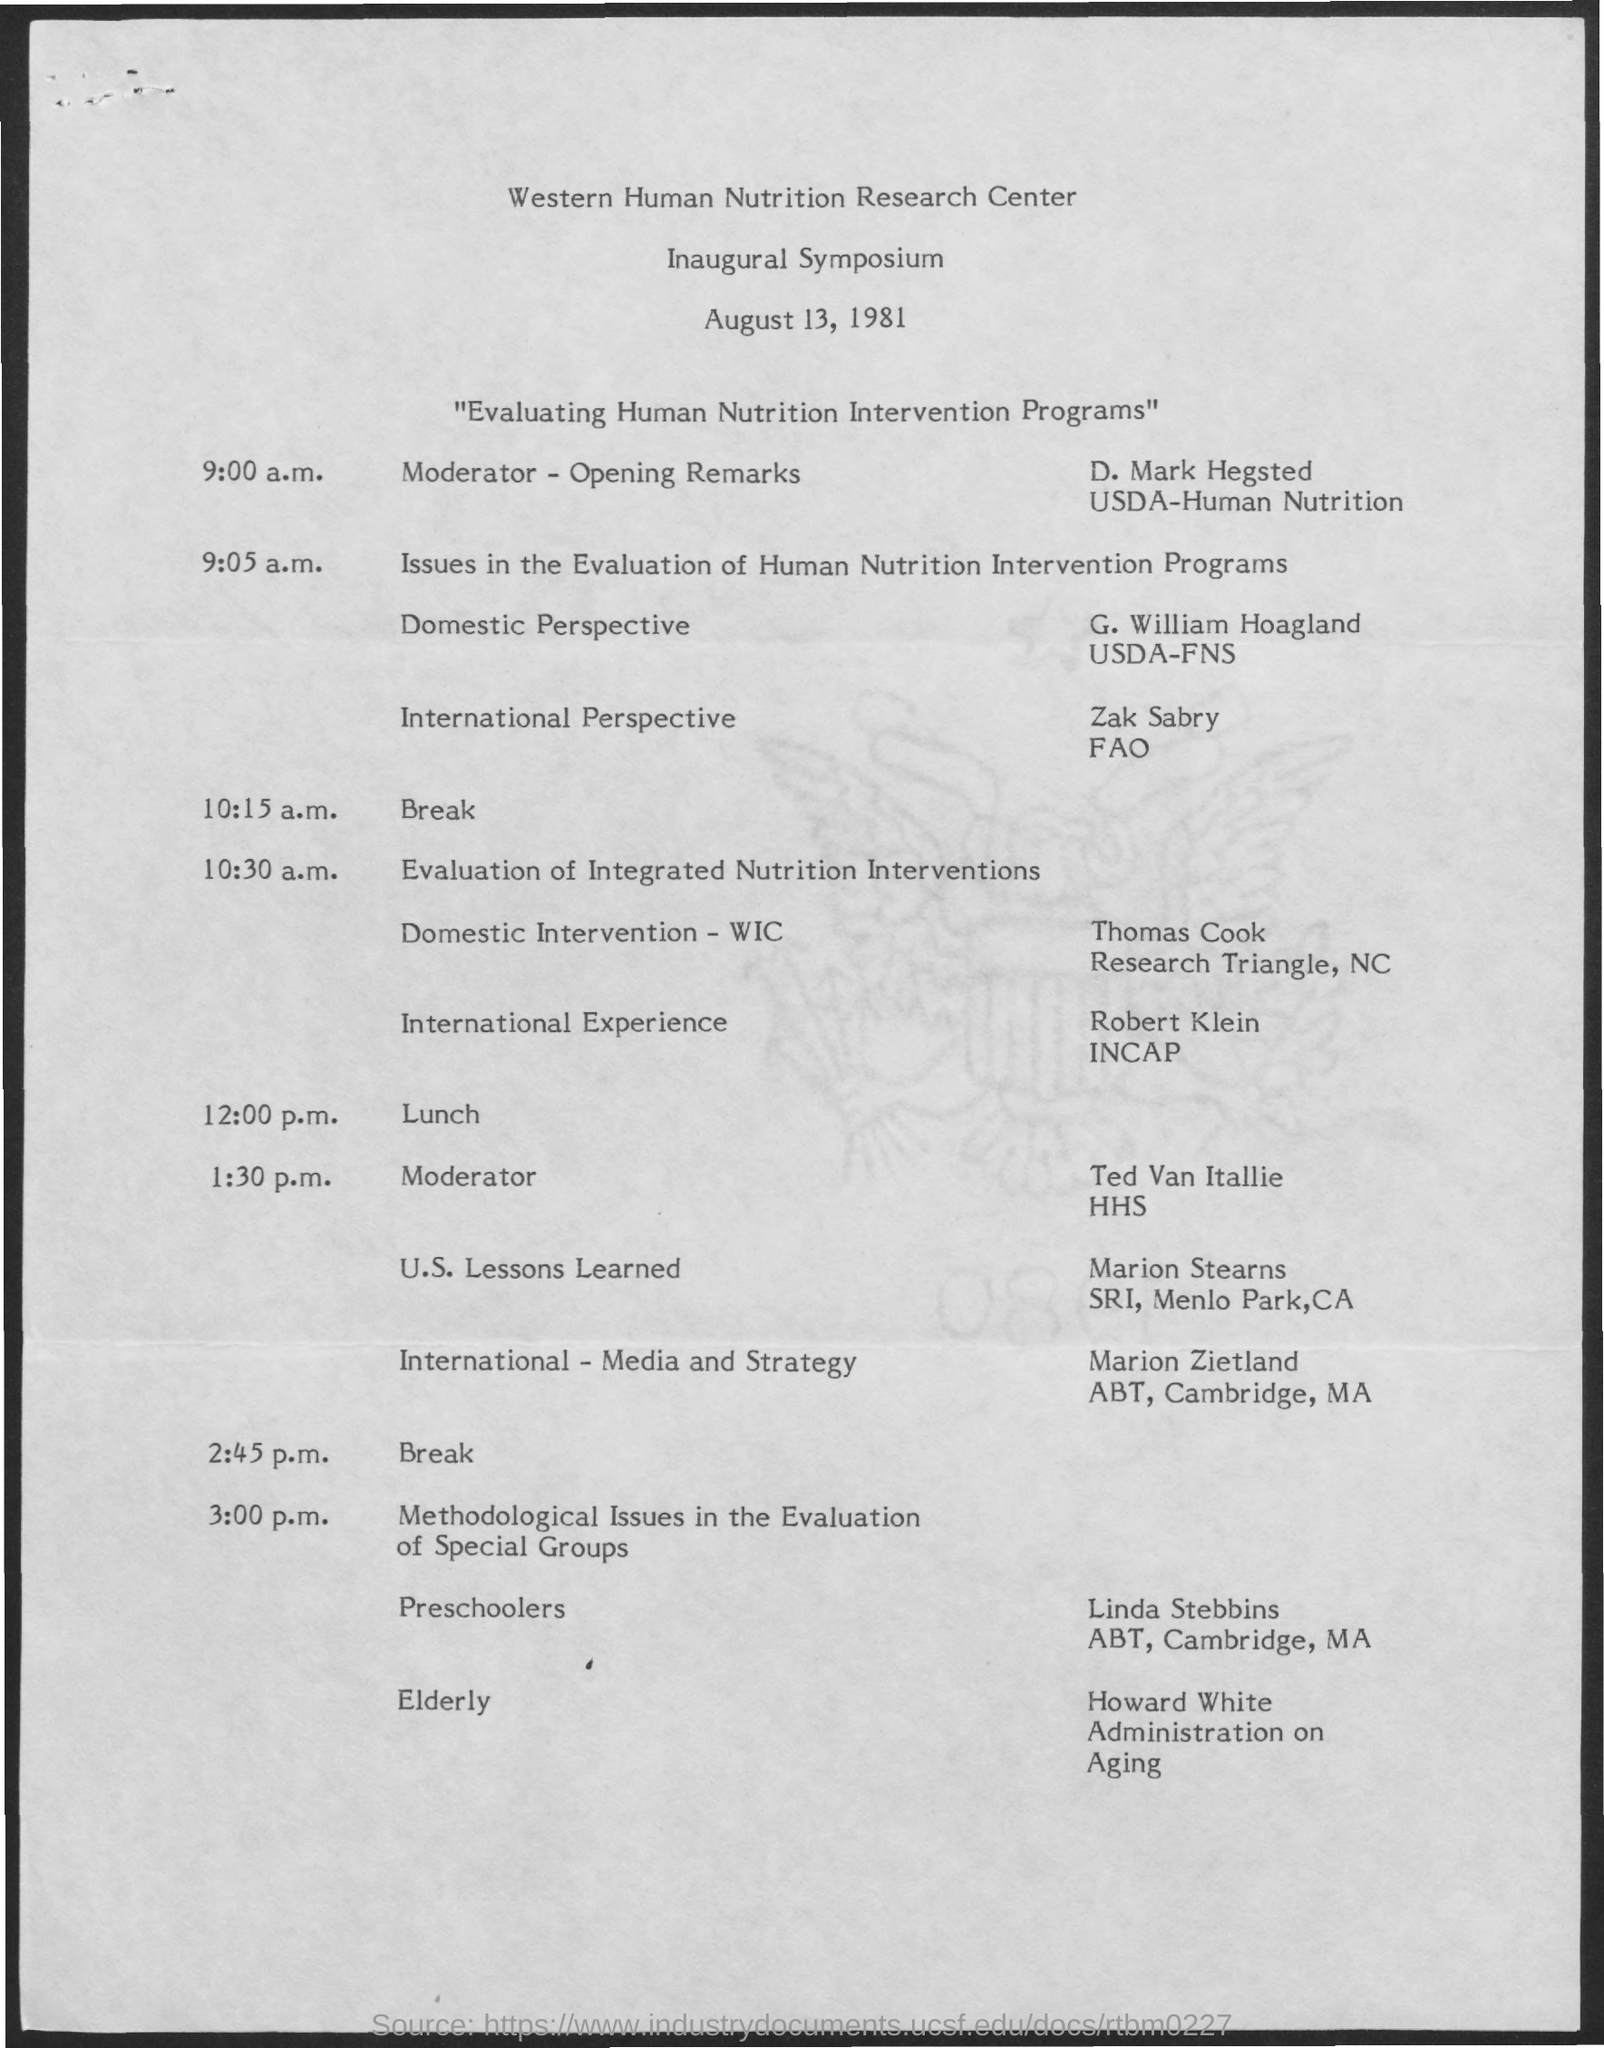When was the Inaugural Symposium of Western Human Nutrition Research Center?
Offer a terse response. August 13, 1981. What was the title of the symposium?
Make the answer very short. "Evaluating Human Nutrition Intervention Programs". Who was the Moderator- Opening Remarks?
Provide a short and direct response. D. Mark Hegsted. Who is the speaker of the topic 'U.S. Lessons learned' ?
Make the answer very short. Marion Stearns. 